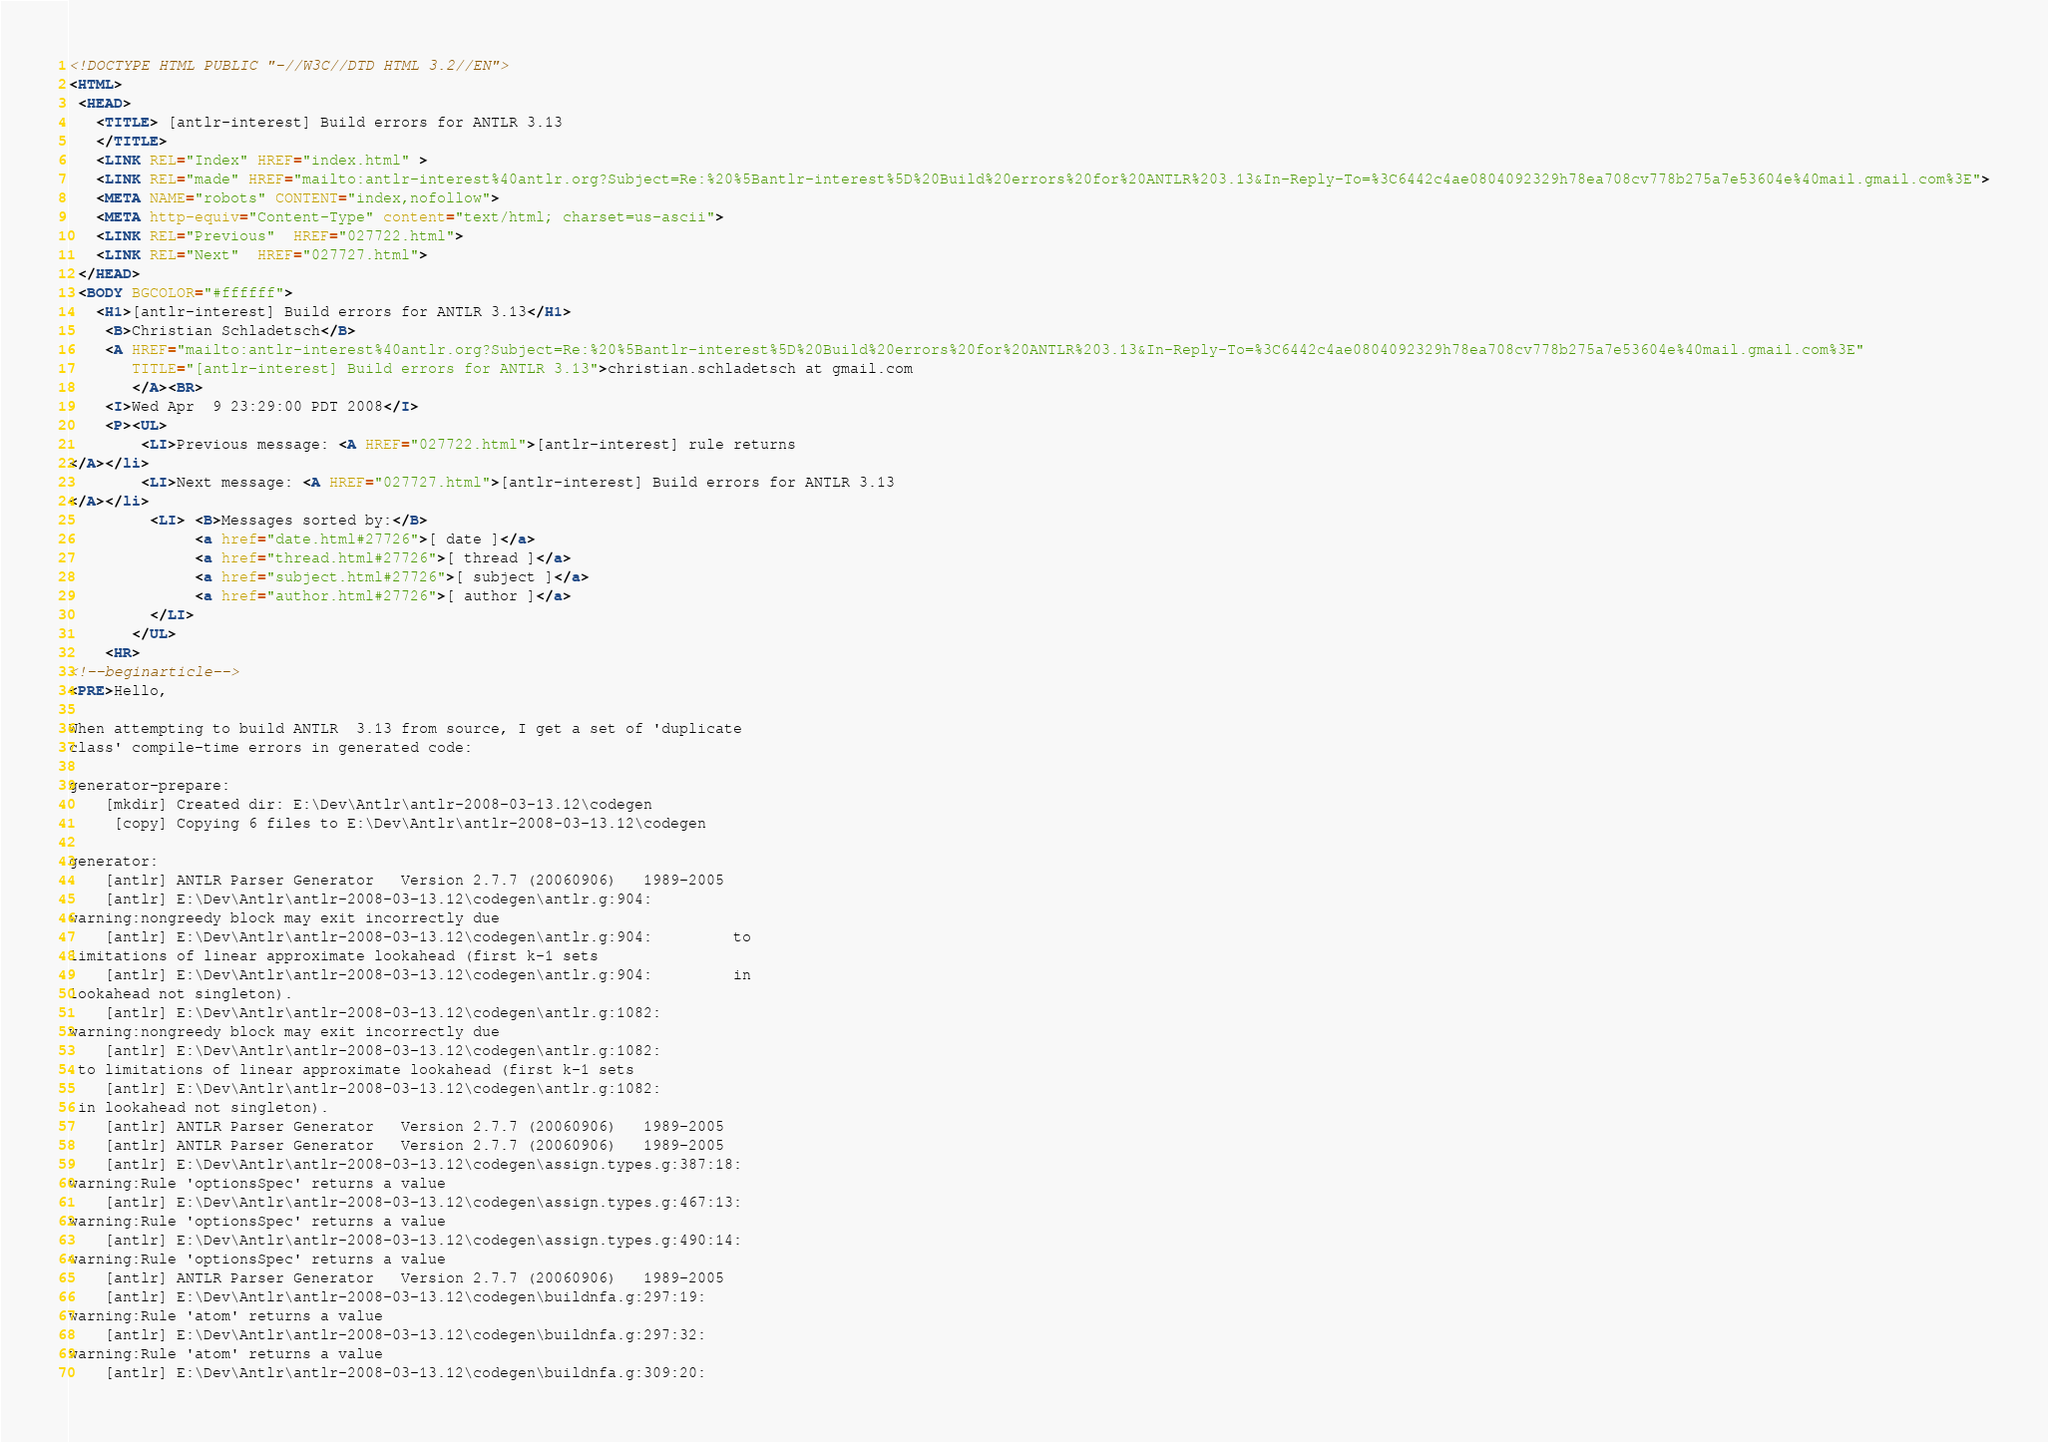Convert code to text. <code><loc_0><loc_0><loc_500><loc_500><_HTML_><!DOCTYPE HTML PUBLIC "-//W3C//DTD HTML 3.2//EN">
<HTML>
 <HEAD>
   <TITLE> [antlr-interest] Build errors for ANTLR 3.13
   </TITLE>
   <LINK REL="Index" HREF="index.html" >
   <LINK REL="made" HREF="mailto:antlr-interest%40antlr.org?Subject=Re:%20%5Bantlr-interest%5D%20Build%20errors%20for%20ANTLR%203.13&In-Reply-To=%3C6442c4ae0804092329h78ea708cv778b275a7e53604e%40mail.gmail.com%3E">
   <META NAME="robots" CONTENT="index,nofollow">
   <META http-equiv="Content-Type" content="text/html; charset=us-ascii">
   <LINK REL="Previous"  HREF="027722.html">
   <LINK REL="Next"  HREF="027727.html">
 </HEAD>
 <BODY BGCOLOR="#ffffff">
   <H1>[antlr-interest] Build errors for ANTLR 3.13</H1>
    <B>Christian Schladetsch</B> 
    <A HREF="mailto:antlr-interest%40antlr.org?Subject=Re:%20%5Bantlr-interest%5D%20Build%20errors%20for%20ANTLR%203.13&In-Reply-To=%3C6442c4ae0804092329h78ea708cv778b275a7e53604e%40mail.gmail.com%3E"
       TITLE="[antlr-interest] Build errors for ANTLR 3.13">christian.schladetsch at gmail.com
       </A><BR>
    <I>Wed Apr  9 23:29:00 PDT 2008</I>
    <P><UL>
        <LI>Previous message: <A HREF="027722.html">[antlr-interest] rule returns
</A></li>
        <LI>Next message: <A HREF="027727.html">[antlr-interest] Build errors for ANTLR 3.13
</A></li>
         <LI> <B>Messages sorted by:</B> 
              <a href="date.html#27726">[ date ]</a>
              <a href="thread.html#27726">[ thread ]</a>
              <a href="subject.html#27726">[ subject ]</a>
              <a href="author.html#27726">[ author ]</a>
         </LI>
       </UL>
    <HR>  
<!--beginarticle-->
<PRE>Hello,

When attempting to build ANTLR  3.13 from source, I get a set of 'duplicate
class' compile-time errors in generated code:

generator-prepare:
    [mkdir] Created dir: E:\Dev\Antlr\antlr-2008-03-13.12\codegen
     [copy] Copying 6 files to E:\Dev\Antlr\antlr-2008-03-13.12\codegen

generator:
    [antlr] ANTLR Parser Generator   Version 2.7.7 (20060906)   1989-2005
    [antlr] E:\Dev\Antlr\antlr-2008-03-13.12\codegen\antlr.g:904:
warning:nongreedy block may exit incorrectly due
    [antlr] E:\Dev\Antlr\antlr-2008-03-13.12\codegen\antlr.g:904:         to
limitations of linear approximate lookahead (first k-1 sets
    [antlr] E:\Dev\Antlr\antlr-2008-03-13.12\codegen\antlr.g:904:         in
lookahead not singleton).
    [antlr] E:\Dev\Antlr\antlr-2008-03-13.12\codegen\antlr.g:1082:
warning:nongreedy block may exit incorrectly due
    [antlr] E:\Dev\Antlr\antlr-2008-03-13.12\codegen\antlr.g:1082:
 to limitations of linear approximate lookahead (first k-1 sets
    [antlr] E:\Dev\Antlr\antlr-2008-03-13.12\codegen\antlr.g:1082:
 in lookahead not singleton).
    [antlr] ANTLR Parser Generator   Version 2.7.7 (20060906)   1989-2005
    [antlr] ANTLR Parser Generator   Version 2.7.7 (20060906)   1989-2005
    [antlr] E:\Dev\Antlr\antlr-2008-03-13.12\codegen\assign.types.g:387:18:
warning:Rule 'optionsSpec' returns a value
    [antlr] E:\Dev\Antlr\antlr-2008-03-13.12\codegen\assign.types.g:467:13:
warning:Rule 'optionsSpec' returns a value
    [antlr] E:\Dev\Antlr\antlr-2008-03-13.12\codegen\assign.types.g:490:14:
warning:Rule 'optionsSpec' returns a value
    [antlr] ANTLR Parser Generator   Version 2.7.7 (20060906)   1989-2005
    [antlr] E:\Dev\Antlr\antlr-2008-03-13.12\codegen\buildnfa.g:297:19:
warning:Rule 'atom' returns a value
    [antlr] E:\Dev\Antlr\antlr-2008-03-13.12\codegen\buildnfa.g:297:32:
warning:Rule 'atom' returns a value
    [antlr] E:\Dev\Antlr\antlr-2008-03-13.12\codegen\buildnfa.g:309:20:</code> 